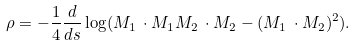<formula> <loc_0><loc_0><loc_500><loc_500>\rho = - \frac { 1 } { 4 } \frac { d } { d s } \log ( M _ { 1 } \, \cdot M _ { 1 } M _ { 2 } \, \cdot M _ { 2 } - ( M _ { 1 } \, \cdot M _ { 2 } ) ^ { 2 } ) .</formula> 